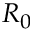Convert formula to latex. <formula><loc_0><loc_0><loc_500><loc_500>R _ { 0 }</formula> 